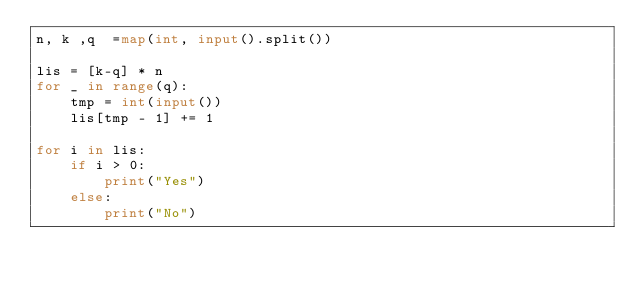<code> <loc_0><loc_0><loc_500><loc_500><_Python_>n, k ,q  =map(int, input().split())

lis = [k-q] * n
for _ in range(q):
    tmp = int(input())
    lis[tmp - 1] += 1

for i in lis:
    if i > 0:
        print("Yes")
    else:
        print("No")</code> 